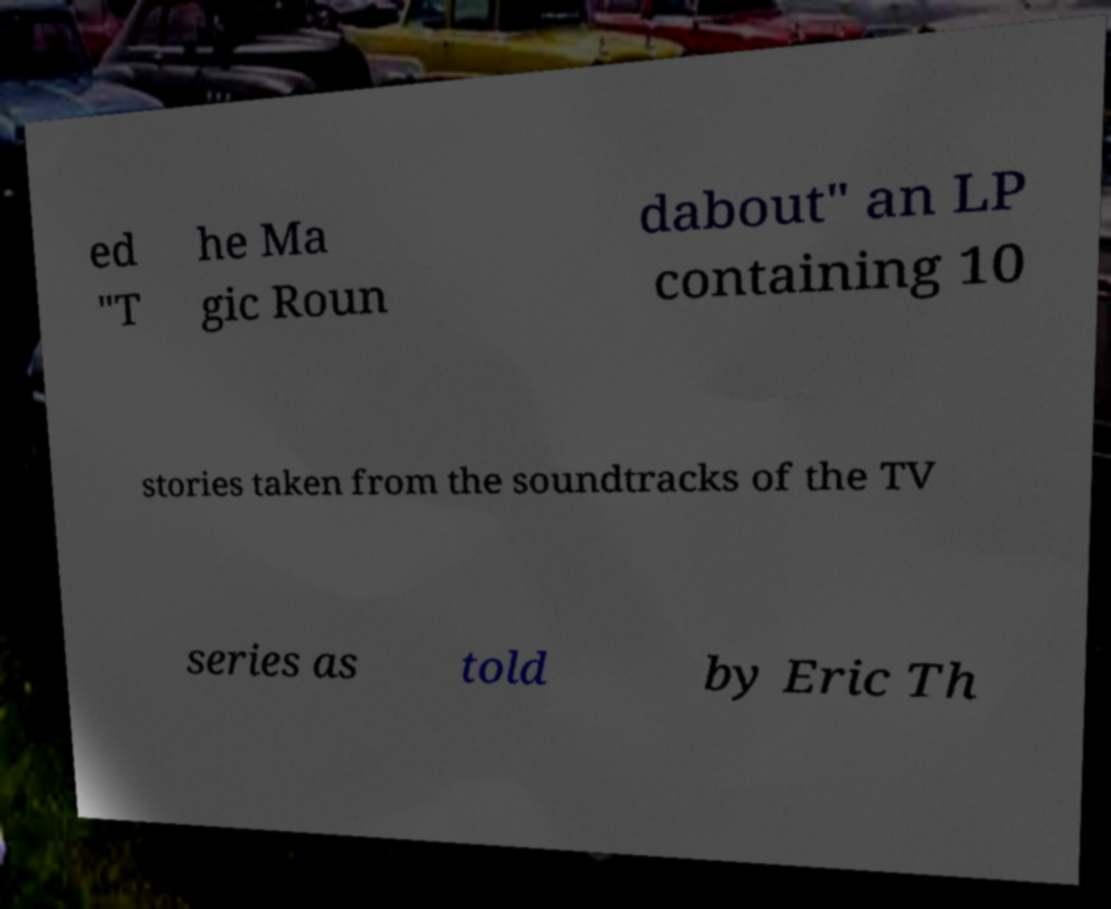Please read and relay the text visible in this image. What does it say? ed "T he Ma gic Roun dabout" an LP containing 10 stories taken from the soundtracks of the TV series as told by Eric Th 